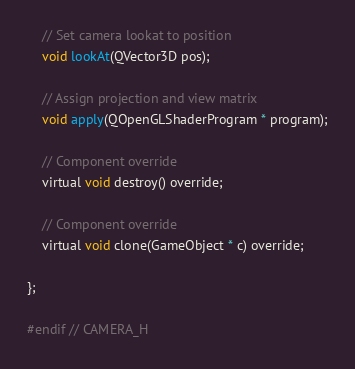<code> <loc_0><loc_0><loc_500><loc_500><_C_>    // Set camera lookat to position
    void lookAt(QVector3D pos);

    // Assign projection and view matrix
    void apply(QOpenGLShaderProgram * program);

    // Component override
    virtual void destroy() override;

    // Component override
    virtual void clone(GameObject * c) override;

};

#endif // CAMERA_H
</code> 